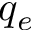<formula> <loc_0><loc_0><loc_500><loc_500>q _ { e }</formula> 